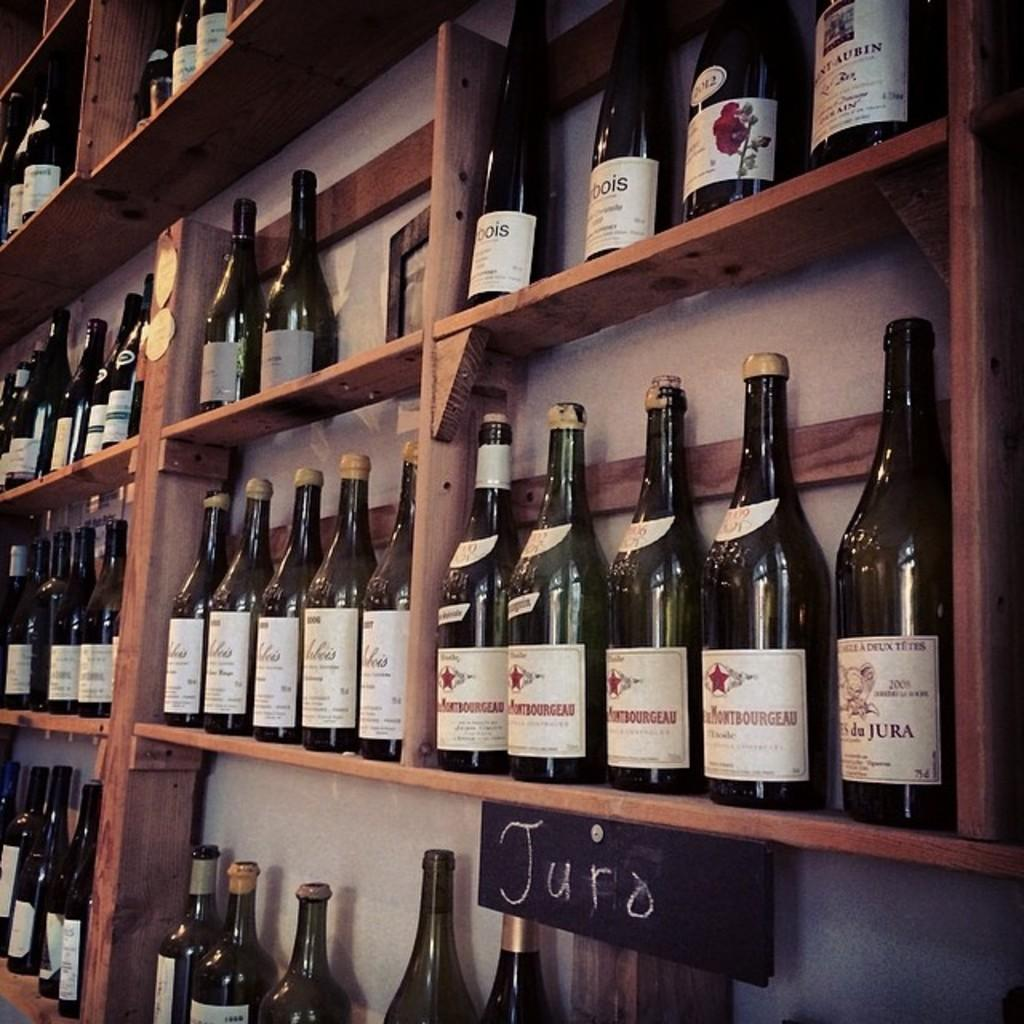<image>
Present a compact description of the photo's key features. Bottles on a set of wooden shelves with the world Juro written on them. 